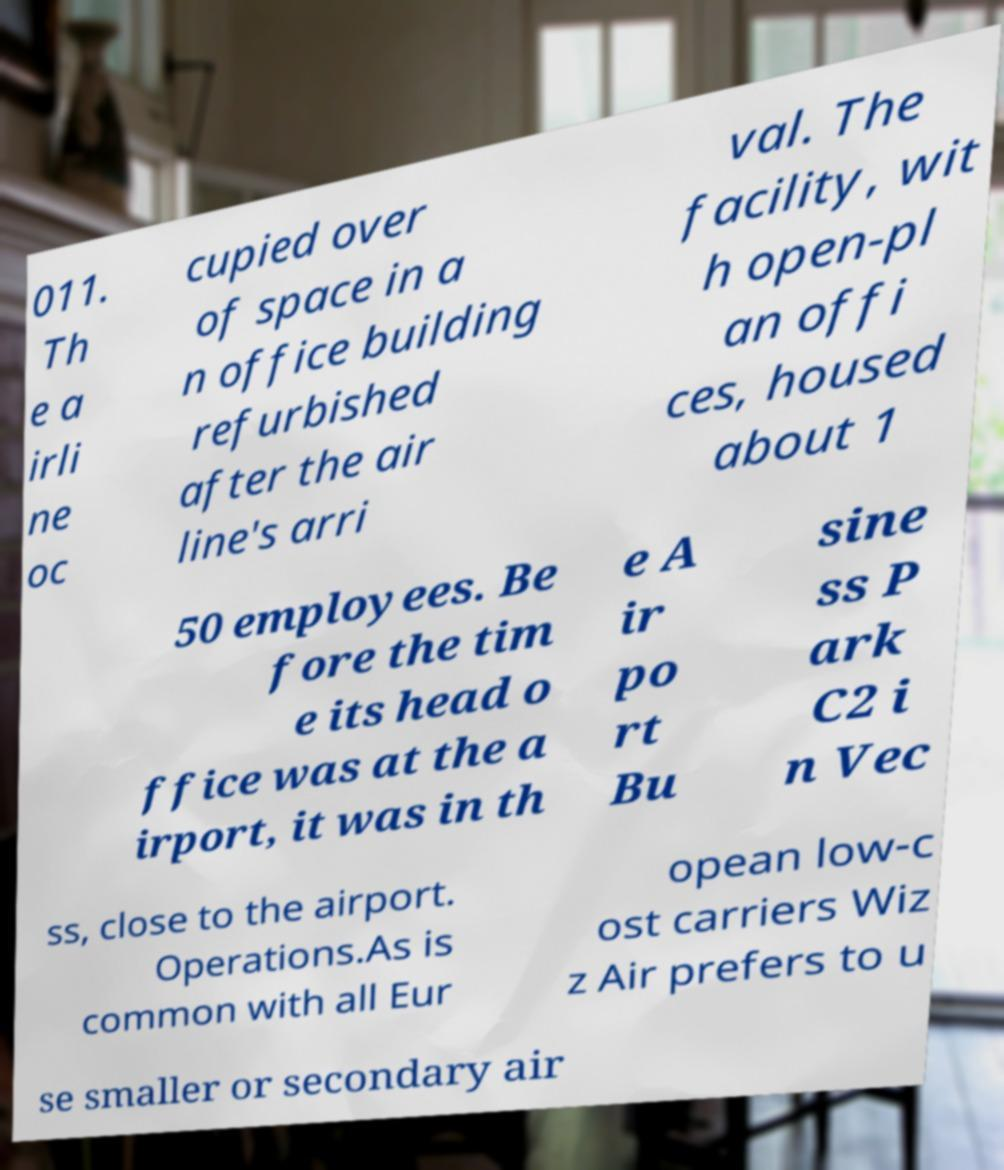I need the written content from this picture converted into text. Can you do that? 011. Th e a irli ne oc cupied over of space in a n office building refurbished after the air line's arri val. The facility, wit h open-pl an offi ces, housed about 1 50 employees. Be fore the tim e its head o ffice was at the a irport, it was in th e A ir po rt Bu sine ss P ark C2 i n Vec ss, close to the airport. Operations.As is common with all Eur opean low-c ost carriers Wiz z Air prefers to u se smaller or secondary air 